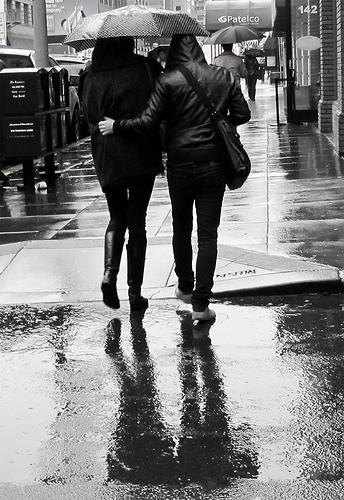What relationship do the persons sharing the umbrella have?

Choices:
A) strangers
B) enemies
C) intimate
D) newly met intimate 